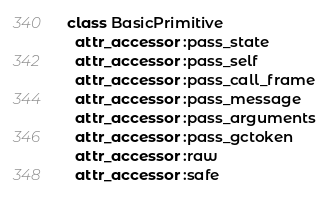<code> <loc_0><loc_0><loc_500><loc_500><_Ruby_>class BasicPrimitive
  attr_accessor :pass_state
  attr_accessor :pass_self
  attr_accessor :pass_call_frame
  attr_accessor :pass_message
  attr_accessor :pass_arguments
  attr_accessor :pass_gctoken
  attr_accessor :raw
  attr_accessor :safe</code> 